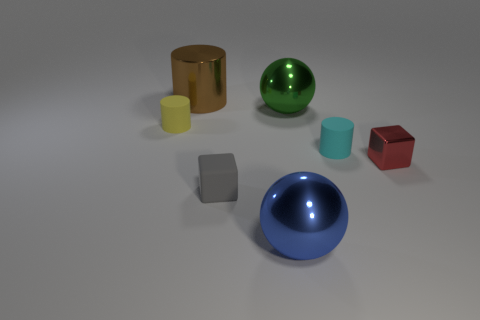Add 3 green spheres. How many objects exist? 10 Subtract all balls. How many objects are left? 5 Add 6 small gray blocks. How many small gray blocks exist? 7 Subtract 1 cyan cylinders. How many objects are left? 6 Subtract all small yellow cylinders. Subtract all cyan rubber things. How many objects are left? 5 Add 2 small red objects. How many small red objects are left? 3 